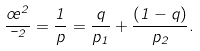Convert formula to latex. <formula><loc_0><loc_0><loc_500><loc_500>\frac { \sigma ^ { 2 } } { \mu ^ { 2 } } = \frac { 1 } { p } = \frac { q } { p _ { 1 } } + \frac { ( 1 - q ) } { p _ { 2 } } .</formula> 